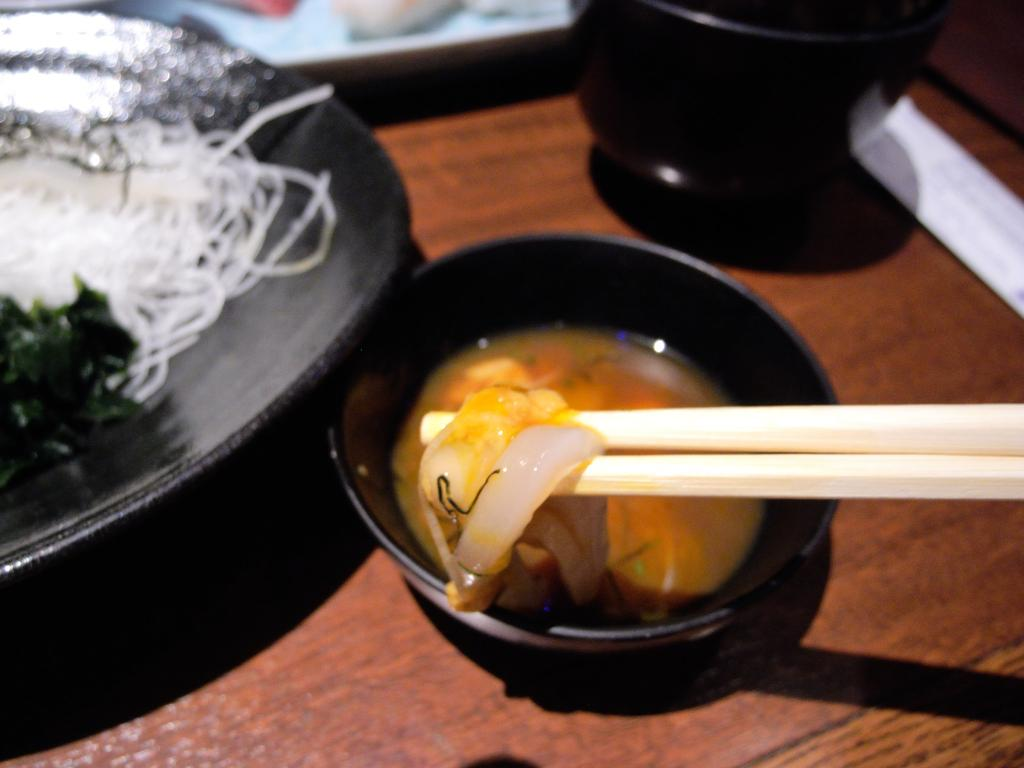What type of food is in the plate in the image? The type of food in the plate is not specified in the facts. What type of food is in the bowl in the image? The type of food in the bowl is not specified in the facts. What material is the surface that the food is on? The surface is made of wood. What utensils are present with the food? Chopsticks are present with the food. What can be seen at the top of the image? The facts mention unspecified objects visible at the top of the image. What type of shade is covering the food in the image? There is no shade covering the food in the image. What type of print is visible on the wooden surface in the image? The facts do not mention any print on the wooden surface. How many pizzas are visible in the image? There is no mention of pizzas in the image. 